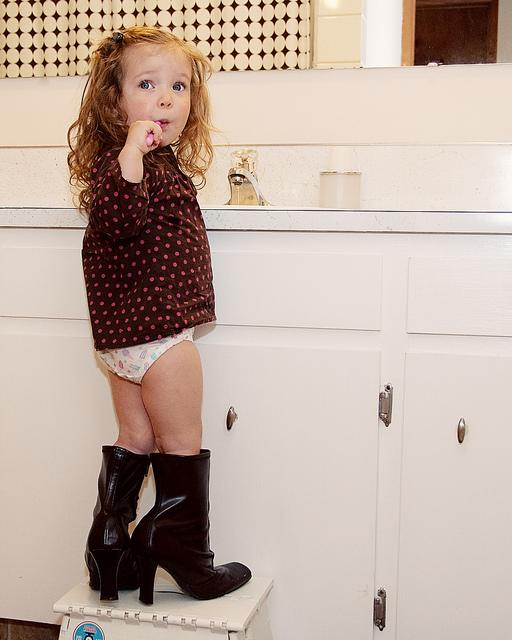Which piece of attire is abnormal for the child to wear? Please explain your reasoning. boots. A small child is standing at the counter wearing boots with no pants. 